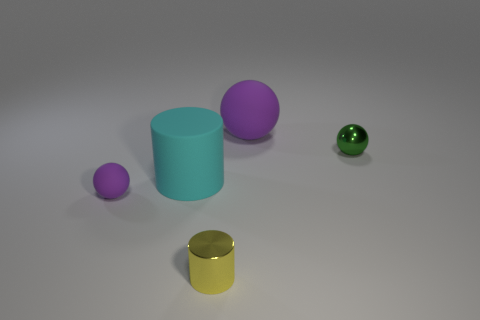Add 4 small things. How many objects exist? 9 Subtract all balls. How many objects are left? 2 Add 4 yellow metallic cylinders. How many yellow metallic cylinders are left? 5 Add 2 purple spheres. How many purple spheres exist? 4 Subtract 0 blue cylinders. How many objects are left? 5 Subtract all tiny yellow balls. Subtract all small rubber objects. How many objects are left? 4 